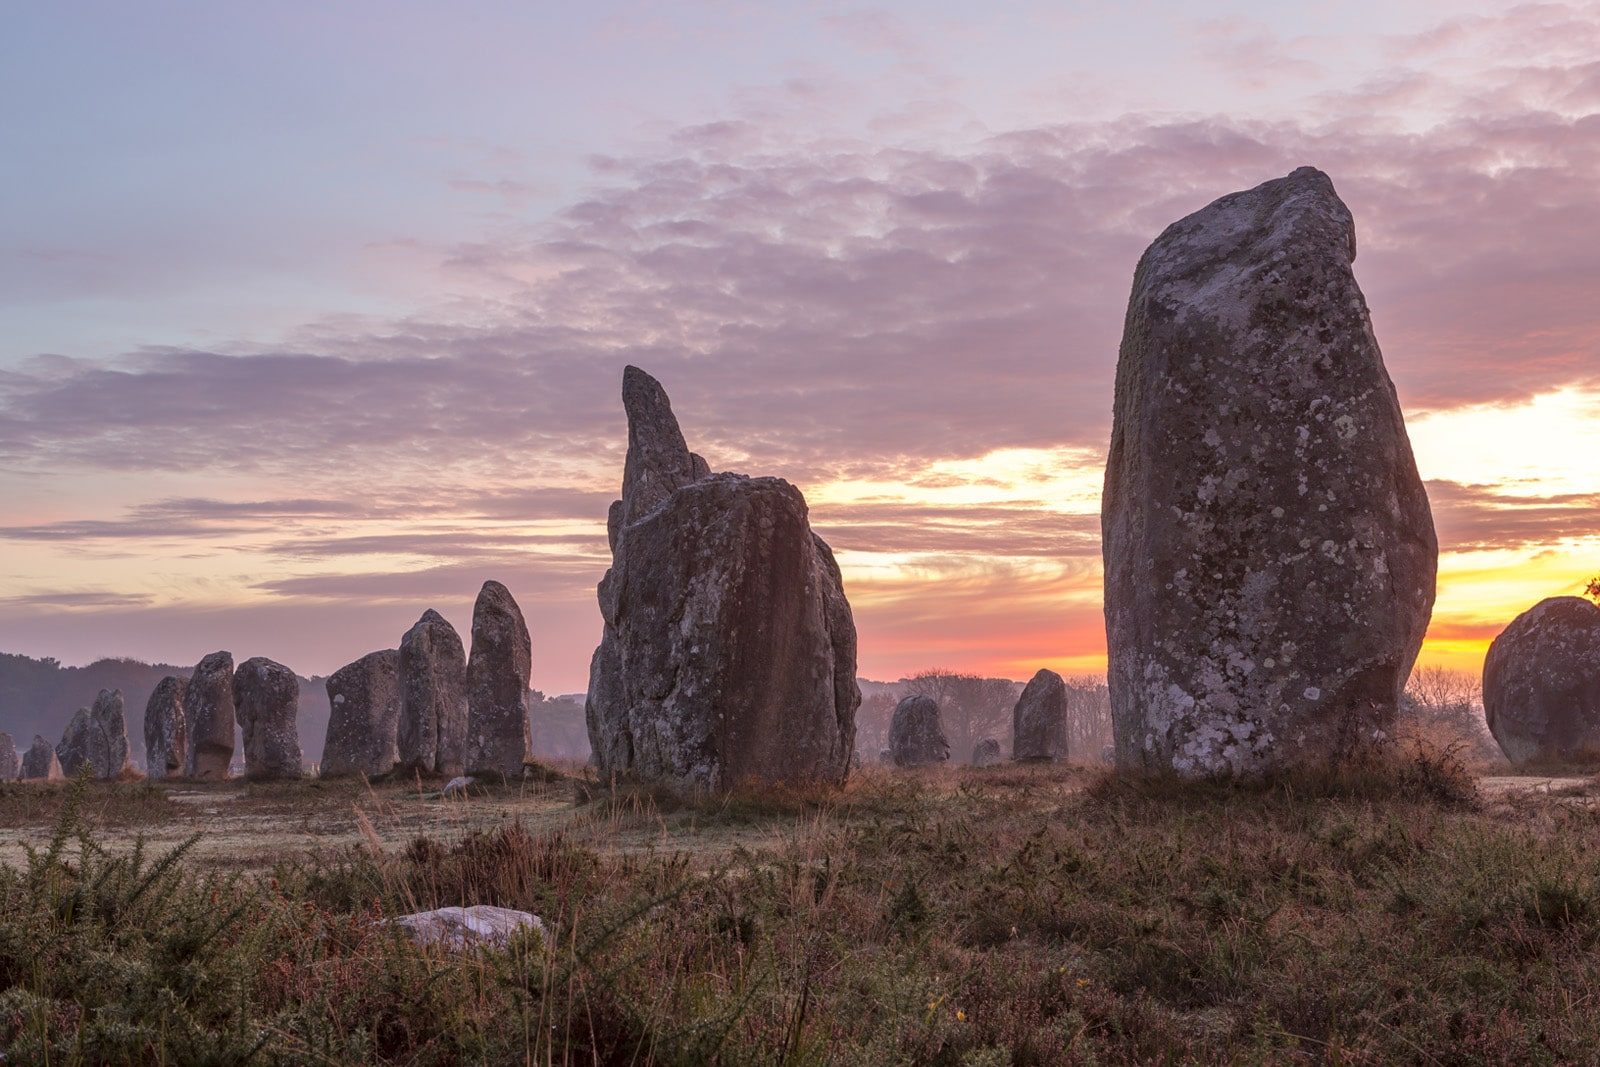What is this photo about? This image beautifully depicts the Carnac stones, an awe-inspiring and historically significant landmark situated in Brittany, France. These ancient megalithic stones are meticulously aligned in rows, with the largest stones prominently displayed in the foreground. The perspective captured here is from ground level, accentuating the impressive size and grandeur of these remarkable structures. The photograph is taken at sunrise, with the sun starting to lift over the horizon, casting a golden and orange hue that warmly bathes the entire scene. The contrast between the warm sunlight and the cooler tones of the sky and grass creates a mesmerizing and tranquil atmosphere. It is a moment that offers a glimpse into the past, showcasing the meticulous arrangement and historical significance of these enigmatic stones. 